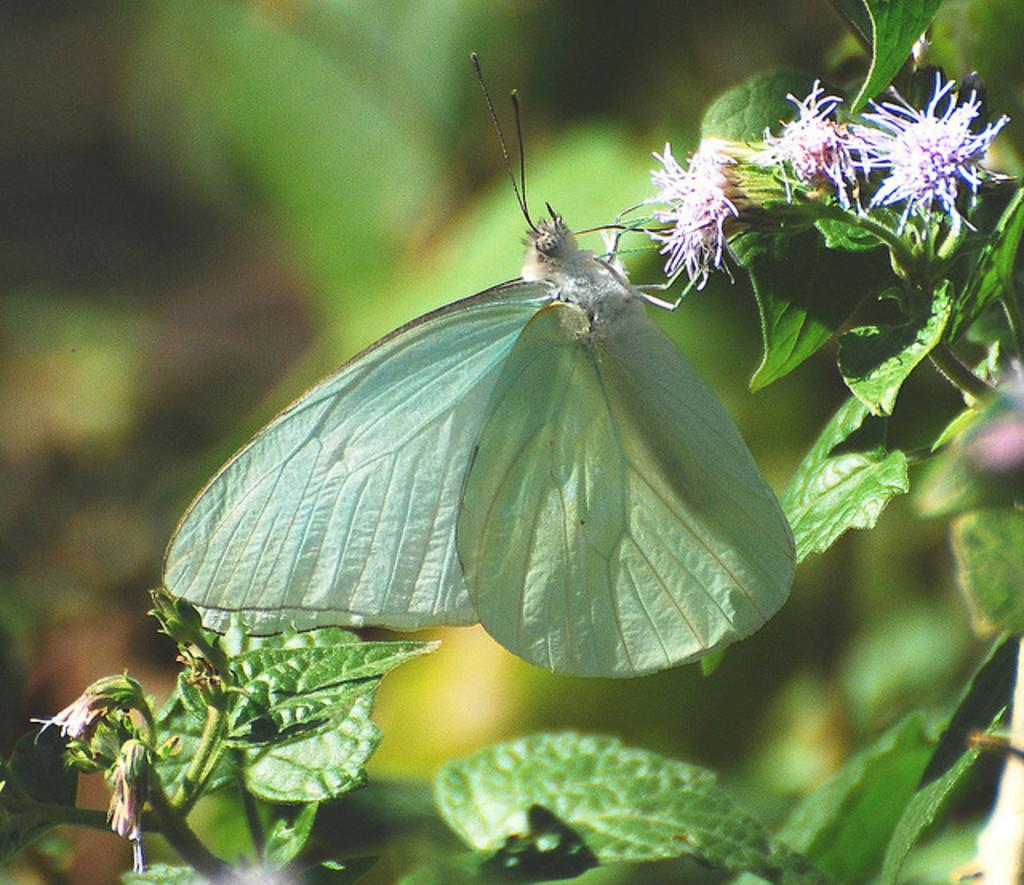What can be observed about the background of the picture? The background of the picture is blurred. What type of plant elements are present in the image? There are leaves, buds, flowers, and stems in the image. Are there any animals or insects visible in the image? Yes, there is a butterfly in the image. What type of drink is being served in the image? There is no drink present in the image; it features plant elements and a butterfly. What type of guide is visible in the image? There is no guide present in the image; it features plant elements and a butterfly. 